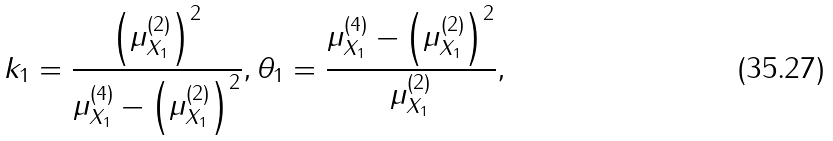Convert formula to latex. <formula><loc_0><loc_0><loc_500><loc_500>k _ { 1 } = \frac { \left ( \mu ^ { ( 2 ) } _ { X _ { 1 } } \right ) ^ { 2 } } { \mu _ { X _ { 1 } } ^ { ( 4 ) } - \left ( \mu ^ { ( 2 ) } _ { X _ { 1 } } \right ) ^ { 2 } } , \theta _ { 1 } = \frac { \mu _ { X _ { 1 } } ^ { ( 4 ) } - \left ( \mu ^ { ( 2 ) } _ { X _ { 1 } } \right ) ^ { 2 } } { \mu ^ { ( 2 ) } _ { X _ { 1 } } } ,</formula> 